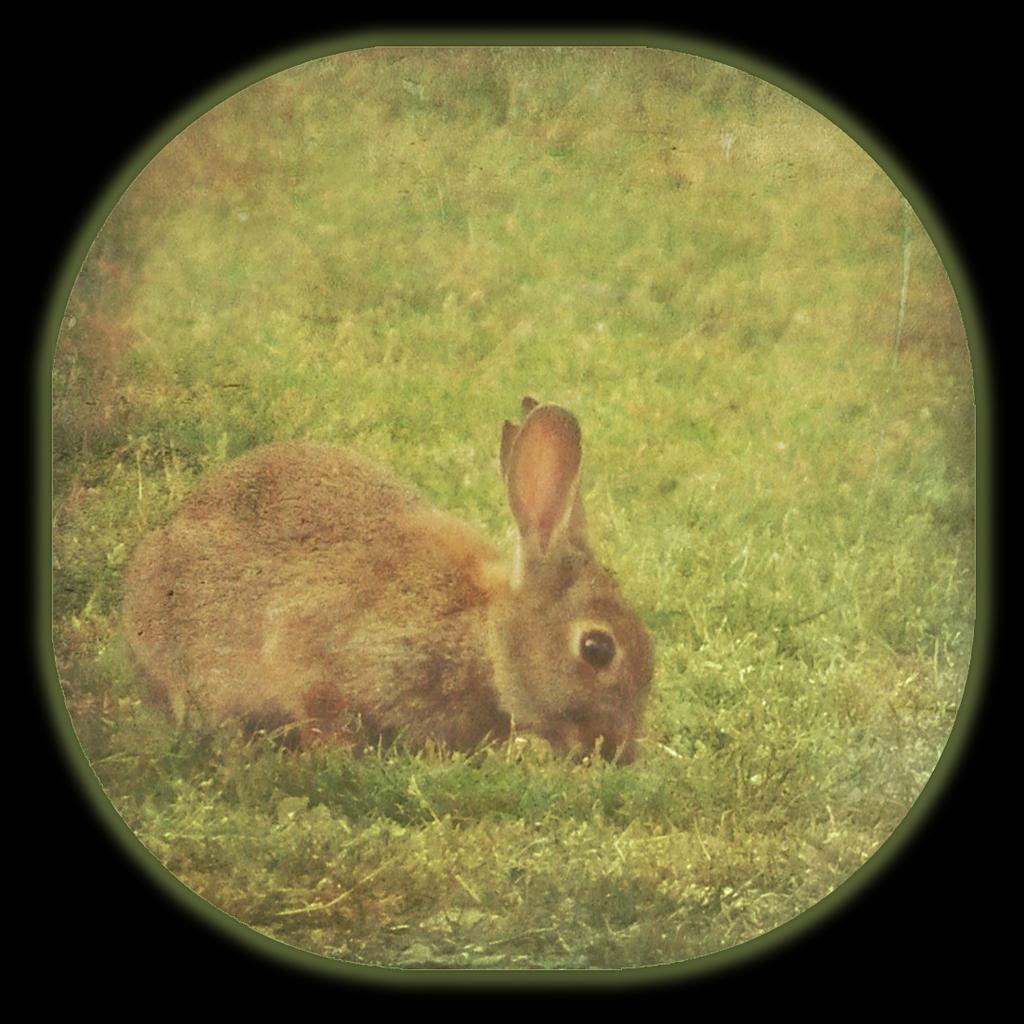What animal is present in the image? There is a rabbit in the image. What color is the rabbit? The rabbit is brown in color. What type of vegetation is visible at the bottom of the image? There is green grass at the bottom of the image. How might the image have been captured? The image appears to be taken with a camera lens. What riddle does the rabbit solve in the image? There is no riddle present in the image, nor is the rabbit solving any riddle. What story is being told through the image? The image does not tell a story; it simply depicts a brown rabbit on green grass. 